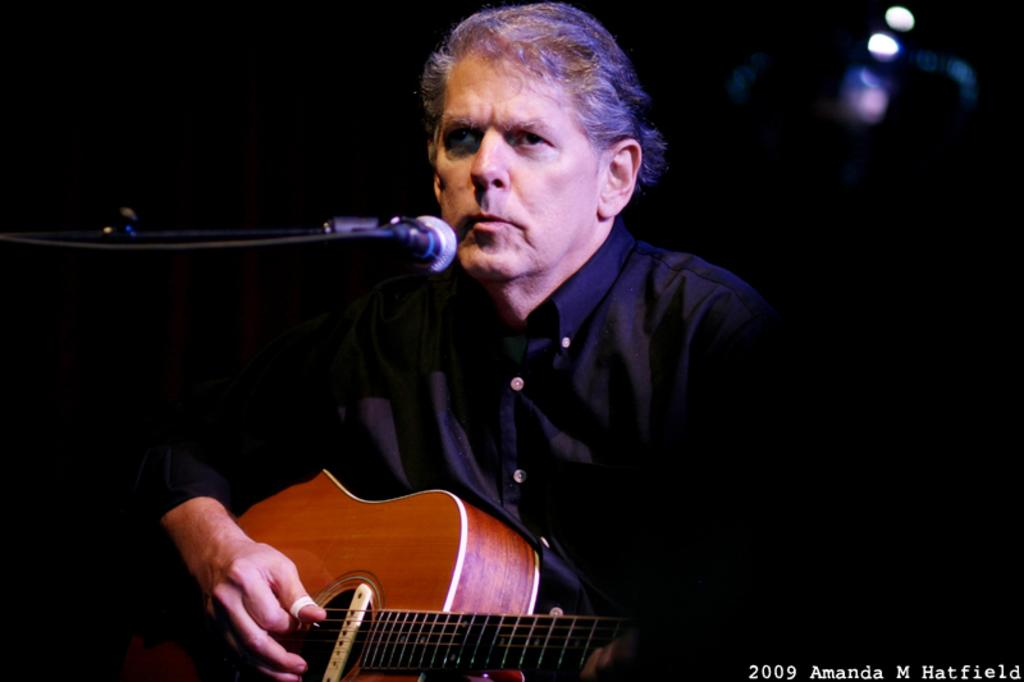What is the man in the image doing? The man is playing a guitar. How is the man holding the guitar? The man is holding the guitar in his hands. What is in front of the man that might be used for amplifying his voice? There is a microphone in front of the man. What can be seen in the background of the image? There are lights visible in the background of the image. What type of advertisement is the man promoting in the image? There is no advertisement present in the image; it simply shows a man playing a guitar with a microphone in front of him. Can you tell me the name of the guide who is leading the man in the image? There is no guide present in the image; the man is playing the guitar on his own. 